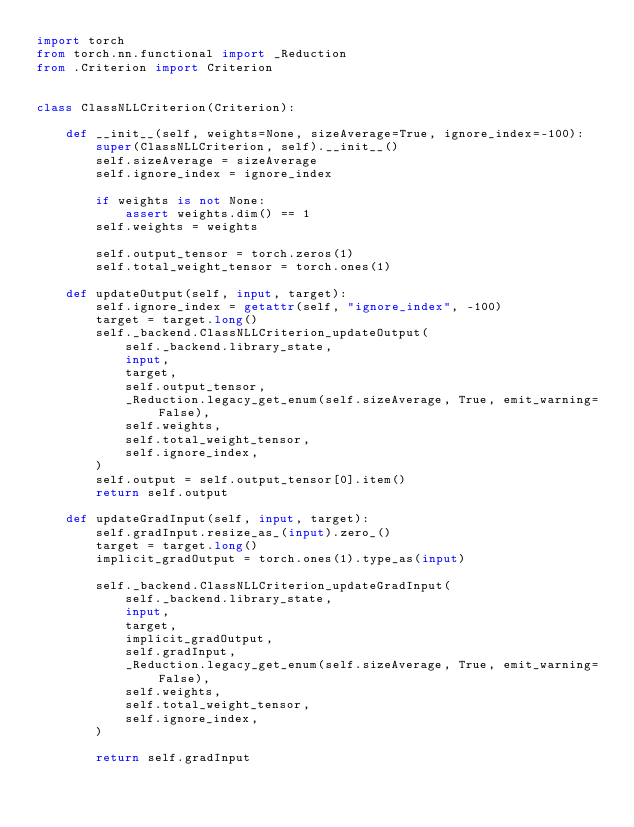Convert code to text. <code><loc_0><loc_0><loc_500><loc_500><_Python_>import torch
from torch.nn.functional import _Reduction
from .Criterion import Criterion


class ClassNLLCriterion(Criterion):

    def __init__(self, weights=None, sizeAverage=True, ignore_index=-100):
        super(ClassNLLCriterion, self).__init__()
        self.sizeAverage = sizeAverage
        self.ignore_index = ignore_index

        if weights is not None:
            assert weights.dim() == 1
        self.weights = weights

        self.output_tensor = torch.zeros(1)
        self.total_weight_tensor = torch.ones(1)

    def updateOutput(self, input, target):
        self.ignore_index = getattr(self, "ignore_index", -100)
        target = target.long()
        self._backend.ClassNLLCriterion_updateOutput(
            self._backend.library_state,
            input,
            target,
            self.output_tensor,
            _Reduction.legacy_get_enum(self.sizeAverage, True, emit_warning=False),
            self.weights,
            self.total_weight_tensor,
            self.ignore_index,
        )
        self.output = self.output_tensor[0].item()
        return self.output

    def updateGradInput(self, input, target):
        self.gradInput.resize_as_(input).zero_()
        target = target.long()
        implicit_gradOutput = torch.ones(1).type_as(input)

        self._backend.ClassNLLCriterion_updateGradInput(
            self._backend.library_state,
            input,
            target,
            implicit_gradOutput,
            self.gradInput,
            _Reduction.legacy_get_enum(self.sizeAverage, True, emit_warning=False),
            self.weights,
            self.total_weight_tensor,
            self.ignore_index,
        )

        return self.gradInput
</code> 